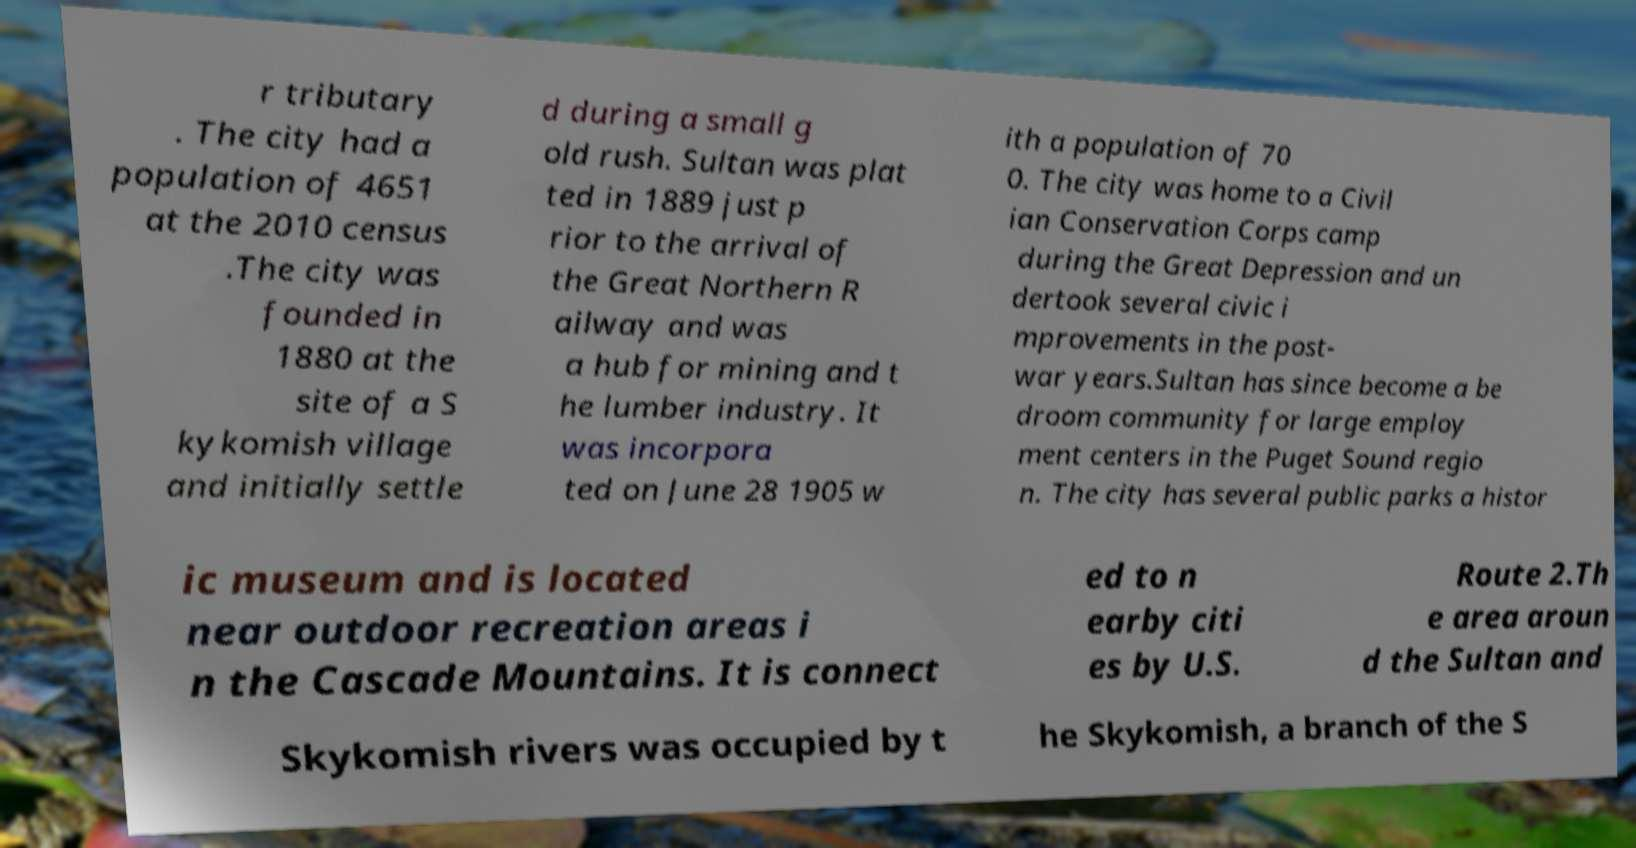Can you read and provide the text displayed in the image?This photo seems to have some interesting text. Can you extract and type it out for me? r tributary . The city had a population of 4651 at the 2010 census .The city was founded in 1880 at the site of a S kykomish village and initially settle d during a small g old rush. Sultan was plat ted in 1889 just p rior to the arrival of the Great Northern R ailway and was a hub for mining and t he lumber industry. It was incorpora ted on June 28 1905 w ith a population of 70 0. The city was home to a Civil ian Conservation Corps camp during the Great Depression and un dertook several civic i mprovements in the post- war years.Sultan has since become a be droom community for large employ ment centers in the Puget Sound regio n. The city has several public parks a histor ic museum and is located near outdoor recreation areas i n the Cascade Mountains. It is connect ed to n earby citi es by U.S. Route 2.Th e area aroun d the Sultan and Skykomish rivers was occupied by t he Skykomish, a branch of the S 